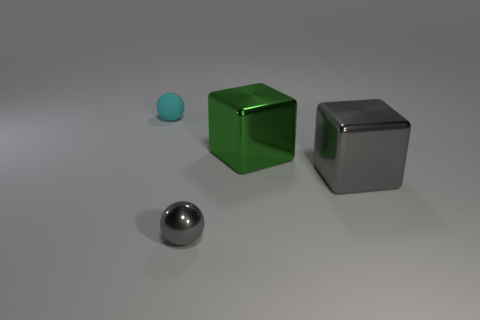Add 4 tiny cyan matte objects. How many objects exist? 8 Subtract all gray balls. Subtract all small cyan things. How many objects are left? 2 Add 1 small cyan things. How many small cyan things are left? 2 Add 2 big red shiny cylinders. How many big red shiny cylinders exist? 2 Subtract 0 blue cubes. How many objects are left? 4 